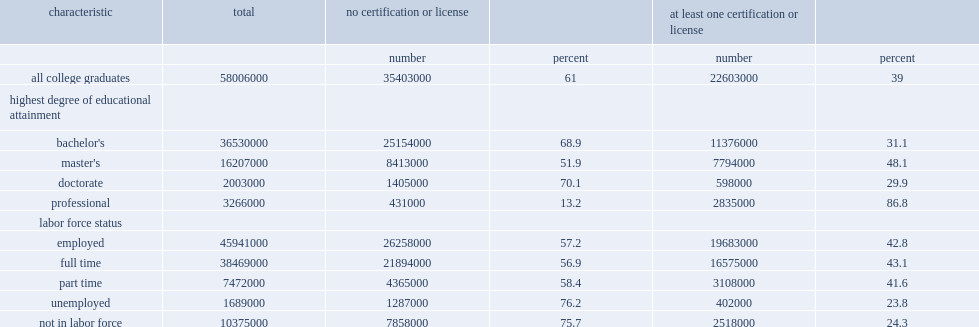Of professional degree holders, how many percent was held at least one certification or license? 86.8. Of professional degree holders, how many percent of all master's degree holders? 48.1. For bachelor's and doctorate degree holders, what was the certification and licensure prevalence rates? 29.9. 